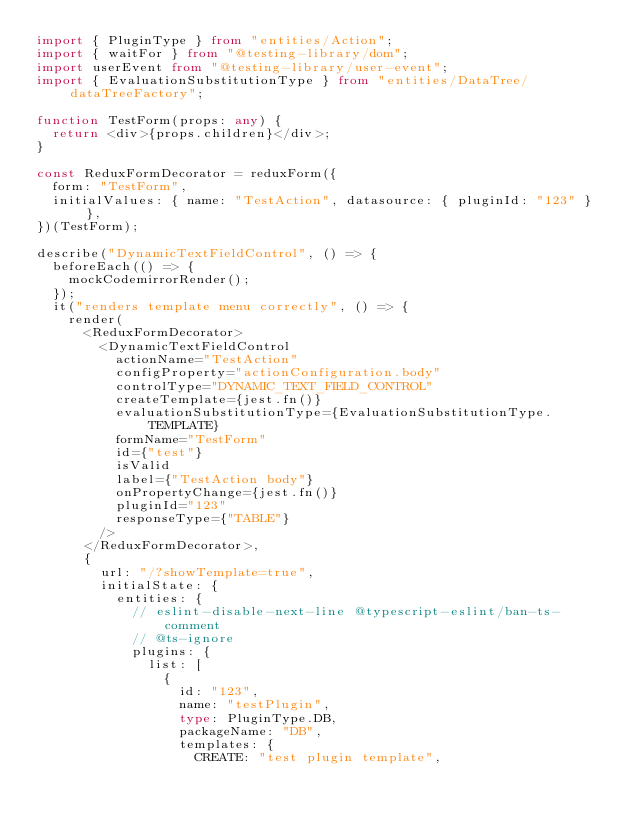Convert code to text. <code><loc_0><loc_0><loc_500><loc_500><_TypeScript_>import { PluginType } from "entities/Action";
import { waitFor } from "@testing-library/dom";
import userEvent from "@testing-library/user-event";
import { EvaluationSubstitutionType } from "entities/DataTree/dataTreeFactory";

function TestForm(props: any) {
  return <div>{props.children}</div>;
}

const ReduxFormDecorator = reduxForm({
  form: "TestForm",
  initialValues: { name: "TestAction", datasource: { pluginId: "123" } },
})(TestForm);

describe("DynamicTextFieldControl", () => {
  beforeEach(() => {
    mockCodemirrorRender();
  });
  it("renders template menu correctly", () => {
    render(
      <ReduxFormDecorator>
        <DynamicTextFieldControl
          actionName="TestAction"
          configProperty="actionConfiguration.body"
          controlType="DYNAMIC_TEXT_FIELD_CONTROL"
          createTemplate={jest.fn()}
          evaluationSubstitutionType={EvaluationSubstitutionType.TEMPLATE}
          formName="TestForm"
          id={"test"}
          isValid
          label={"TestAction body"}
          onPropertyChange={jest.fn()}
          pluginId="123"
          responseType={"TABLE"}
        />
      </ReduxFormDecorator>,
      {
        url: "/?showTemplate=true",
        initialState: {
          entities: {
            // eslint-disable-next-line @typescript-eslint/ban-ts-comment
            // @ts-ignore
            plugins: {
              list: [
                {
                  id: "123",
                  name: "testPlugin",
                  type: PluginType.DB,
                  packageName: "DB",
                  templates: {
                    CREATE: "test plugin template",</code> 